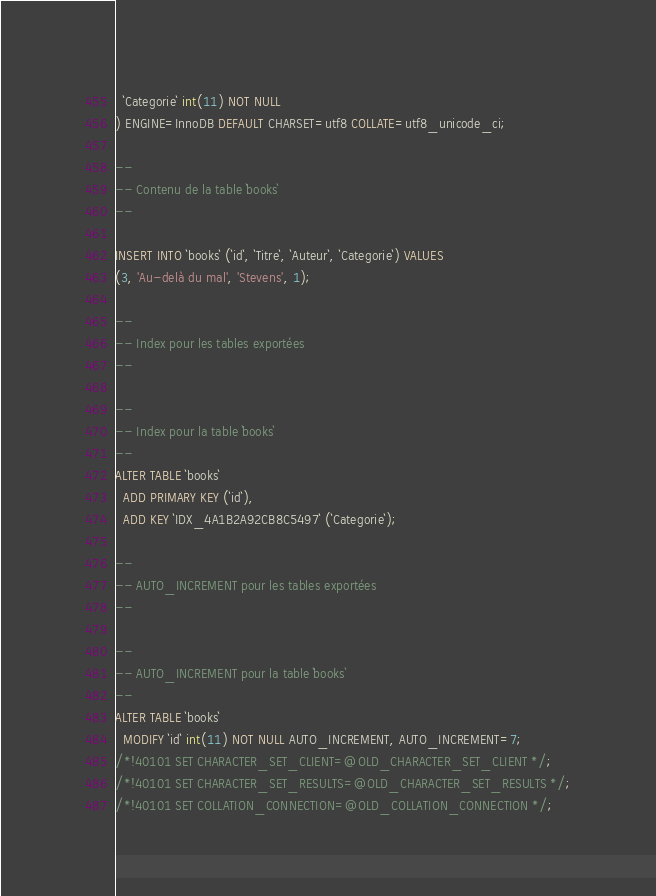Convert code to text. <code><loc_0><loc_0><loc_500><loc_500><_SQL_>  `Categorie` int(11) NOT NULL
) ENGINE=InnoDB DEFAULT CHARSET=utf8 COLLATE=utf8_unicode_ci;

--
-- Contenu de la table `books`
--

INSERT INTO `books` (`id`, `Titre`, `Auteur`, `Categorie`) VALUES
(3, 'Au-delà du mal', 'Stevens', 1);

--
-- Index pour les tables exportées
--

--
-- Index pour la table `books`
--
ALTER TABLE `books`
  ADD PRIMARY KEY (`id`),
  ADD KEY `IDX_4A1B2A92CB8C5497` (`Categorie`);

--
-- AUTO_INCREMENT pour les tables exportées
--

--
-- AUTO_INCREMENT pour la table `books`
--
ALTER TABLE `books`
  MODIFY `id` int(11) NOT NULL AUTO_INCREMENT, AUTO_INCREMENT=7;
/*!40101 SET CHARACTER_SET_CLIENT=@OLD_CHARACTER_SET_CLIENT */;
/*!40101 SET CHARACTER_SET_RESULTS=@OLD_CHARACTER_SET_RESULTS */;
/*!40101 SET COLLATION_CONNECTION=@OLD_COLLATION_CONNECTION */;
</code> 